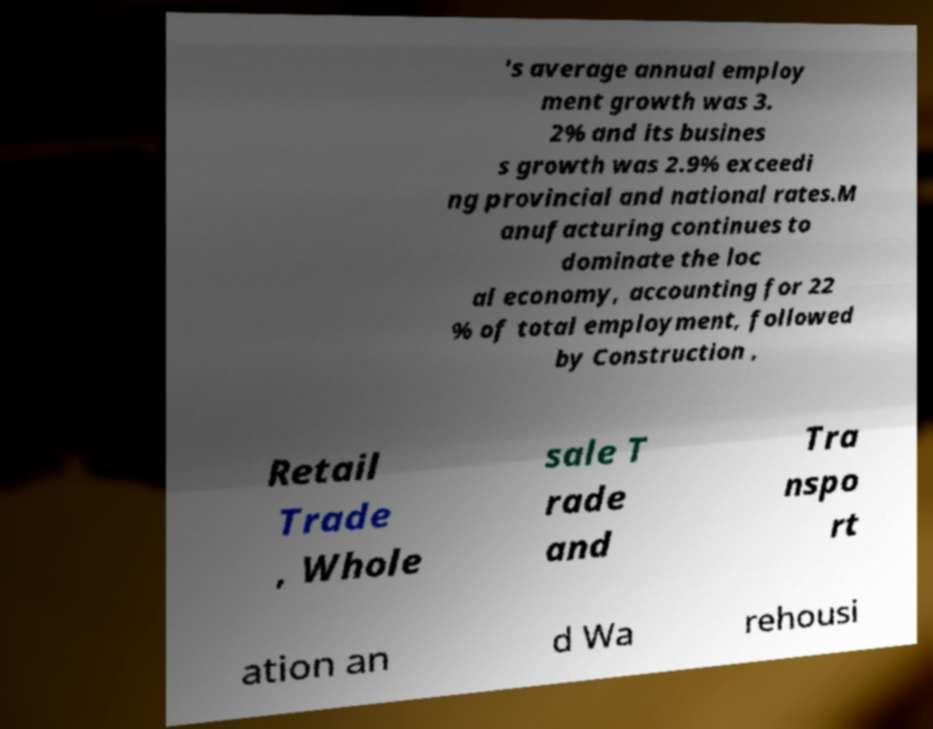What messages or text are displayed in this image? I need them in a readable, typed format. 's average annual employ ment growth was 3. 2% and its busines s growth was 2.9% exceedi ng provincial and national rates.M anufacturing continues to dominate the loc al economy, accounting for 22 % of total employment, followed by Construction , Retail Trade , Whole sale T rade and Tra nspo rt ation an d Wa rehousi 